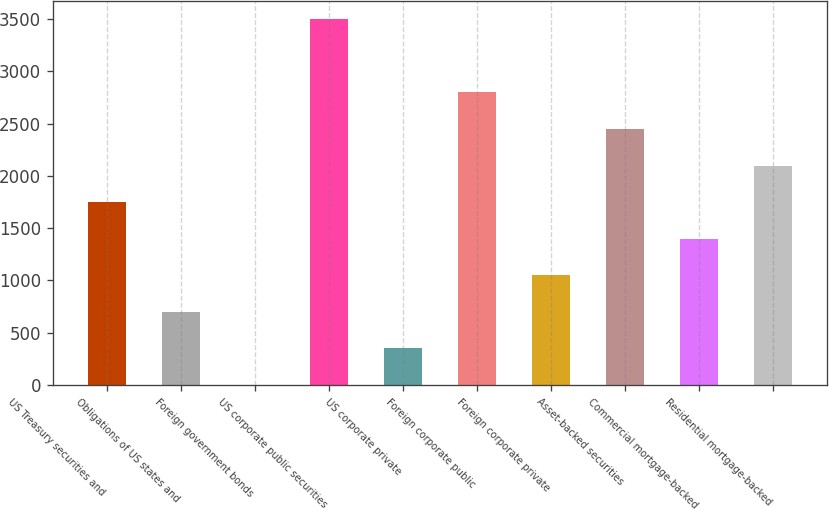Convert chart. <chart><loc_0><loc_0><loc_500><loc_500><bar_chart><fcel>US Treasury securities and<fcel>Obligations of US states and<fcel>Foreign government bonds<fcel>US corporate public securities<fcel>US corporate private<fcel>Foreign corporate public<fcel>Foreign corporate private<fcel>Asset-backed securities<fcel>Commercial mortgage-backed<fcel>Residential mortgage-backed<nl><fcel>1748.97<fcel>700.74<fcel>1.92<fcel>3496.02<fcel>351.33<fcel>2797.2<fcel>1050.15<fcel>2447.79<fcel>1399.56<fcel>2098.38<nl></chart> 